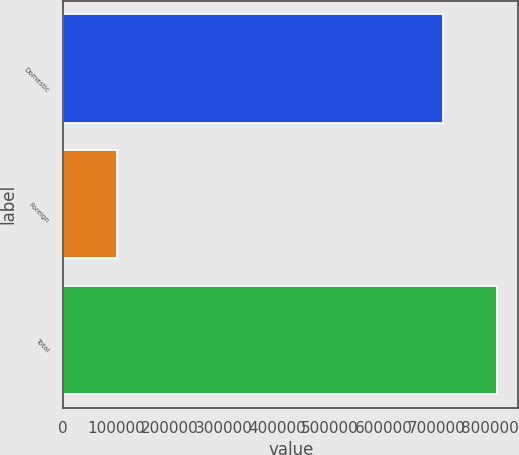Convert chart to OTSL. <chart><loc_0><loc_0><loc_500><loc_500><bar_chart><fcel>Domestic<fcel>Foreign<fcel>Total<nl><fcel>710931<fcel>101019<fcel>811950<nl></chart> 